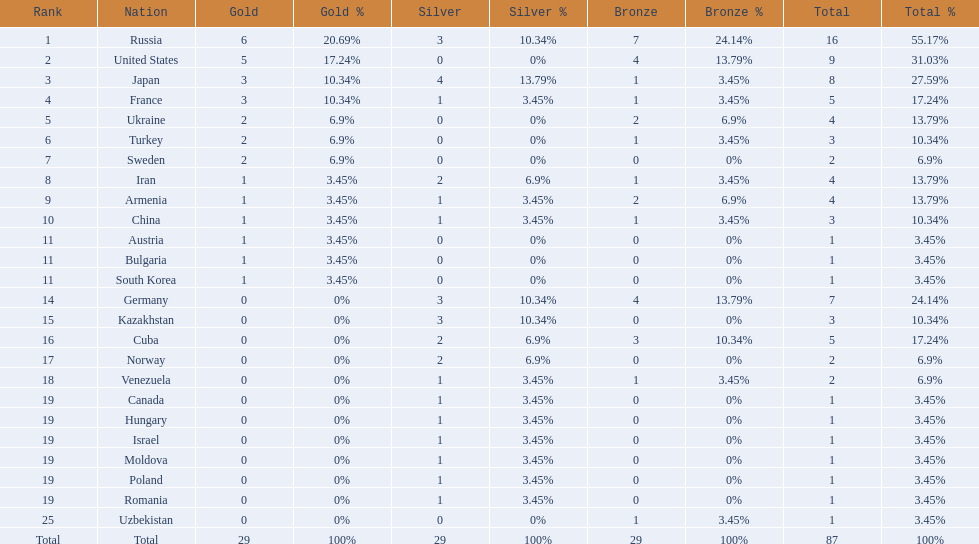What was iran's ranking? 8. What was germany's ranking? 14. Between iran and germany, which was not in the top 10? Germany. 